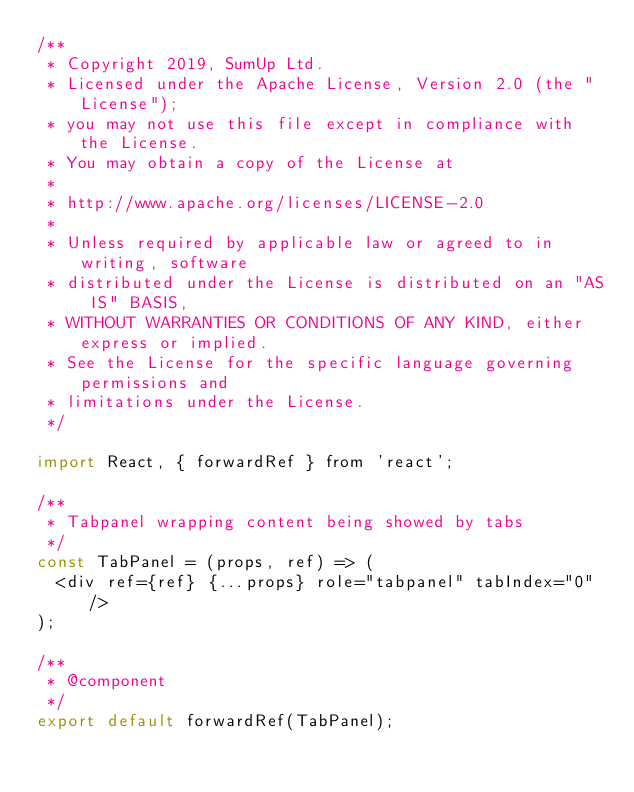Convert code to text. <code><loc_0><loc_0><loc_500><loc_500><_JavaScript_>/**
 * Copyright 2019, SumUp Ltd.
 * Licensed under the Apache License, Version 2.0 (the "License");
 * you may not use this file except in compliance with the License.
 * You may obtain a copy of the License at
 *
 * http://www.apache.org/licenses/LICENSE-2.0
 *
 * Unless required by applicable law or agreed to in writing, software
 * distributed under the License is distributed on an "AS IS" BASIS,
 * WITHOUT WARRANTIES OR CONDITIONS OF ANY KIND, either express or implied.
 * See the License for the specific language governing permissions and
 * limitations under the License.
 */

import React, { forwardRef } from 'react';

/**
 * Tabpanel wrapping content being showed by tabs
 */
const TabPanel = (props, ref) => (
  <div ref={ref} {...props} role="tabpanel" tabIndex="0" />
);

/**
 * @component
 */
export default forwardRef(TabPanel);
</code> 